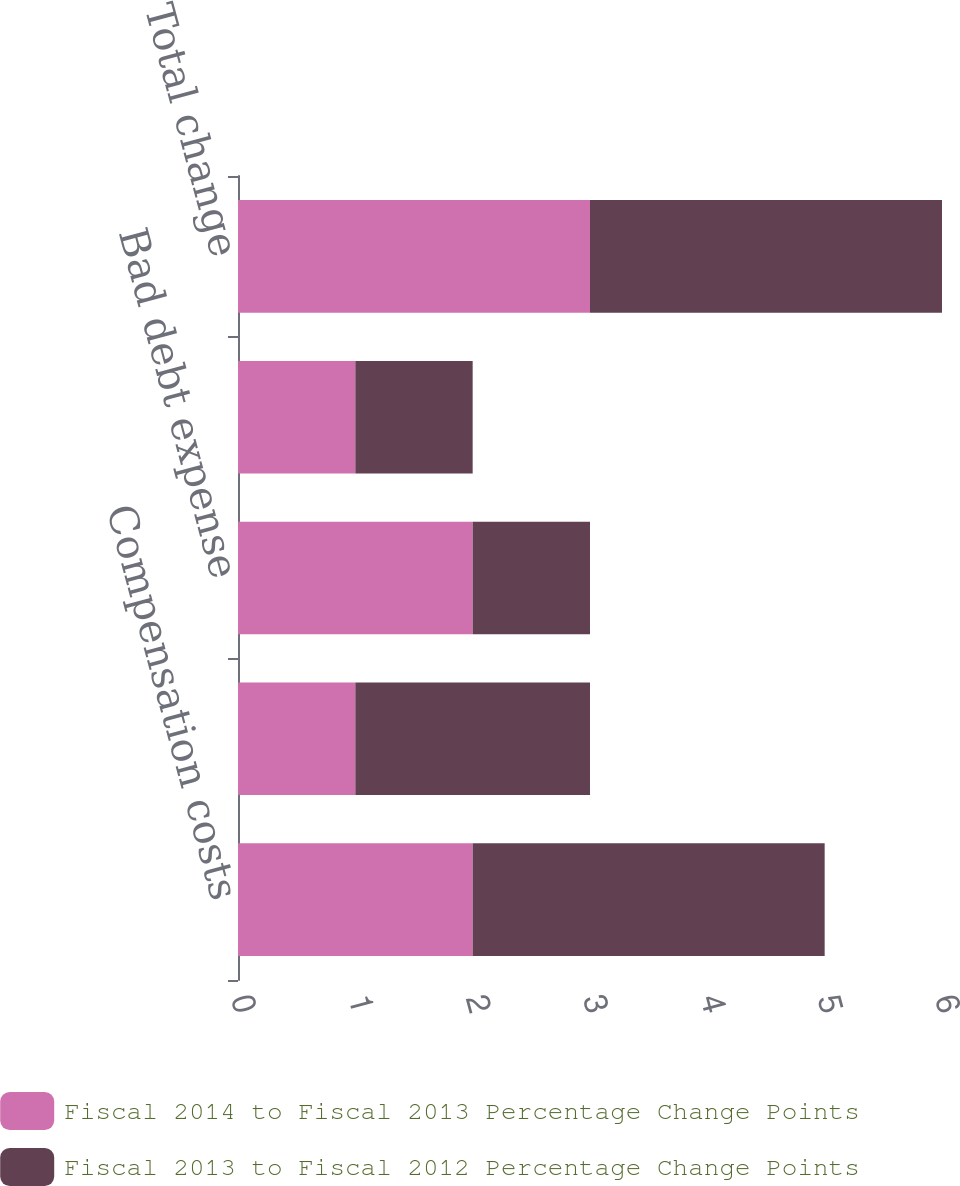Convert chart to OTSL. <chart><loc_0><loc_0><loc_500><loc_500><stacked_bar_chart><ecel><fcel>Compensation costs<fcel>Professional and legal fees<fcel>Bad debt expense<fcel>Other<fcel>Total change<nl><fcel>Fiscal 2014 to Fiscal 2013 Percentage Change Points<fcel>2<fcel>1<fcel>2<fcel>1<fcel>3<nl><fcel>Fiscal 2013 to Fiscal 2012 Percentage Change Points<fcel>3<fcel>2<fcel>1<fcel>1<fcel>3<nl></chart> 